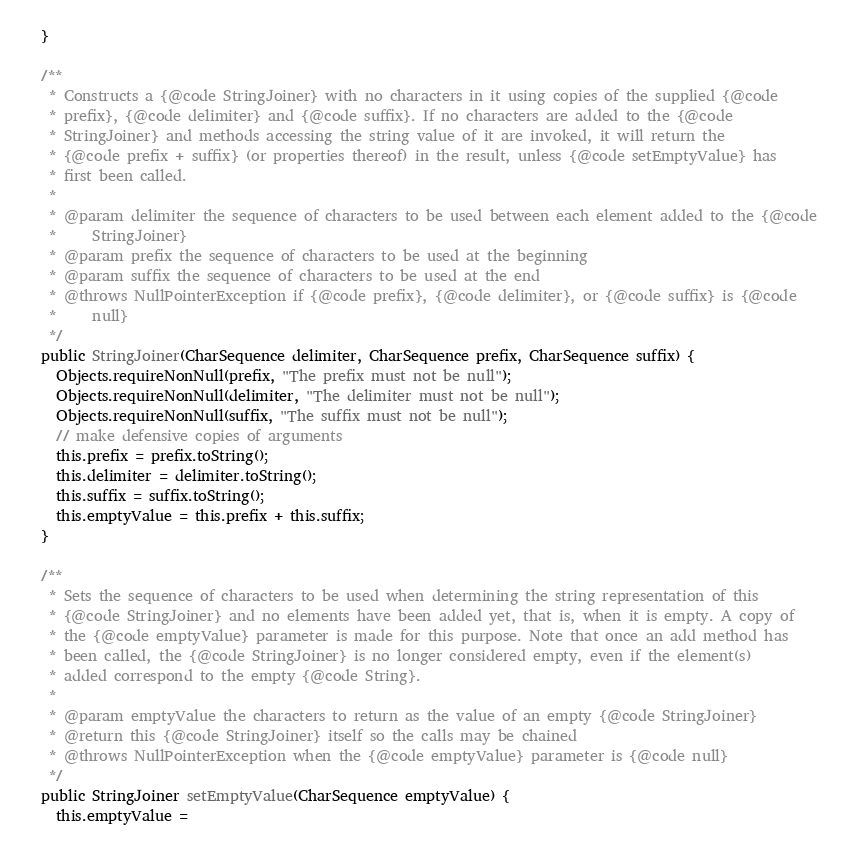<code> <loc_0><loc_0><loc_500><loc_500><_Java_>  }

  /**
   * Constructs a {@code StringJoiner} with no characters in it using copies of the supplied {@code
   * prefix}, {@code delimiter} and {@code suffix}. If no characters are added to the {@code
   * StringJoiner} and methods accessing the string value of it are invoked, it will return the
   * {@code prefix + suffix} (or properties thereof) in the result, unless {@code setEmptyValue} has
   * first been called.
   *
   * @param delimiter the sequence of characters to be used between each element added to the {@code
   *     StringJoiner}
   * @param prefix the sequence of characters to be used at the beginning
   * @param suffix the sequence of characters to be used at the end
   * @throws NullPointerException if {@code prefix}, {@code delimiter}, or {@code suffix} is {@code
   *     null}
   */
  public StringJoiner(CharSequence delimiter, CharSequence prefix, CharSequence suffix) {
    Objects.requireNonNull(prefix, "The prefix must not be null");
    Objects.requireNonNull(delimiter, "The delimiter must not be null");
    Objects.requireNonNull(suffix, "The suffix must not be null");
    // make defensive copies of arguments
    this.prefix = prefix.toString();
    this.delimiter = delimiter.toString();
    this.suffix = suffix.toString();
    this.emptyValue = this.prefix + this.suffix;
  }

  /**
   * Sets the sequence of characters to be used when determining the string representation of this
   * {@code StringJoiner} and no elements have been added yet, that is, when it is empty. A copy of
   * the {@code emptyValue} parameter is made for this purpose. Note that once an add method has
   * been called, the {@code StringJoiner} is no longer considered empty, even if the element(s)
   * added correspond to the empty {@code String}.
   *
   * @param emptyValue the characters to return as the value of an empty {@code StringJoiner}
   * @return this {@code StringJoiner} itself so the calls may be chained
   * @throws NullPointerException when the {@code emptyValue} parameter is {@code null}
   */
  public StringJoiner setEmptyValue(CharSequence emptyValue) {
    this.emptyValue =</code> 